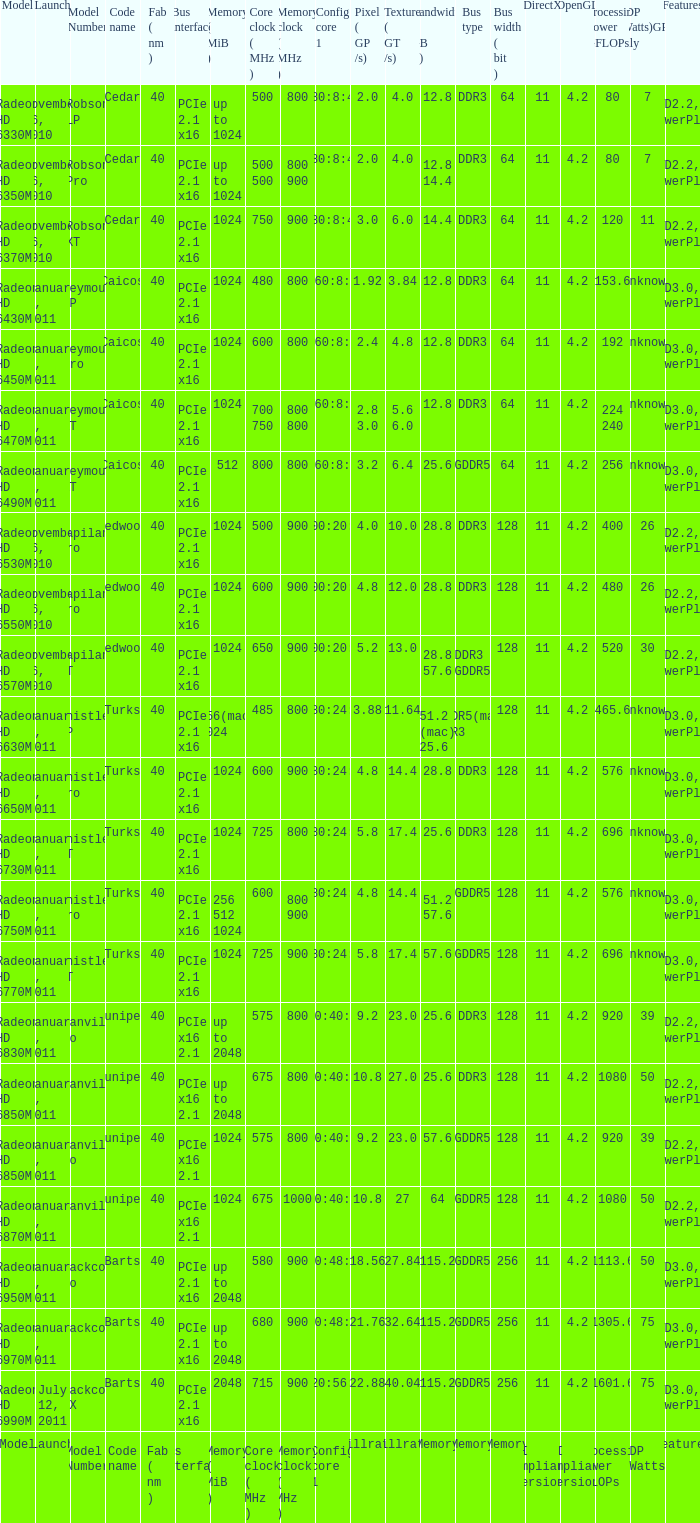Which bus types are available for the texture fill rate? Memory. 